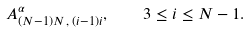Convert formula to latex. <formula><loc_0><loc_0><loc_500><loc_500>A ^ { \alpha } _ { ( N - 1 ) N \, , \, ( i - 1 ) i } , \quad 3 \leq i \leq N - 1 .</formula> 